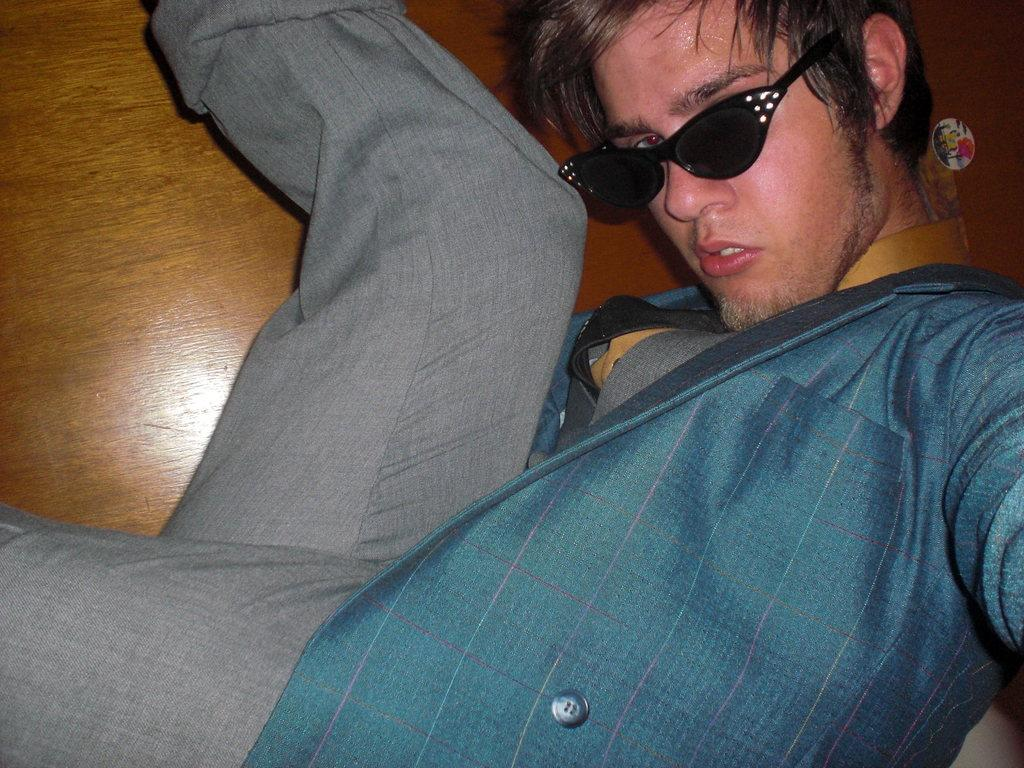What is present in the image? There is a person in the image. Can you describe the person's appearance? The person is wearing spectacles. What type of crime is the person committing in the image? There is no indication of any crime being committed in the image; it only shows a person wearing spectacles. 